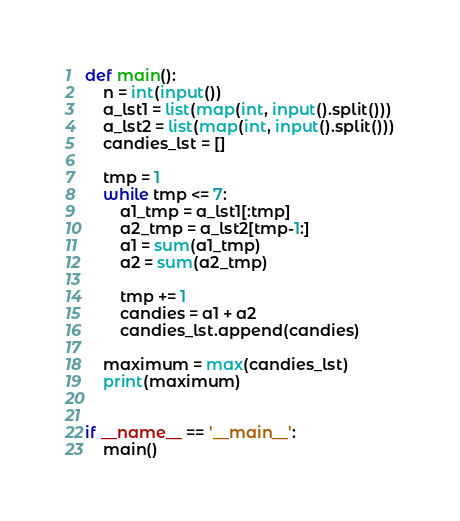<code> <loc_0><loc_0><loc_500><loc_500><_Python_>def main():
    n = int(input())
    a_lst1 = list(map(int, input().split()))
    a_lst2 = list(map(int, input().split()))
    candies_lst = []

    tmp = 1
    while tmp <= 7:
        a1_tmp = a_lst1[:tmp]
        a2_tmp = a_lst2[tmp-1:]
        a1 = sum(a1_tmp)
        a2 = sum(a2_tmp)

        tmp += 1
        candies = a1 + a2
        candies_lst.append(candies)

    maximum = max(candies_lst)
    print(maximum)


if __name__ == '__main__':
    main()</code> 